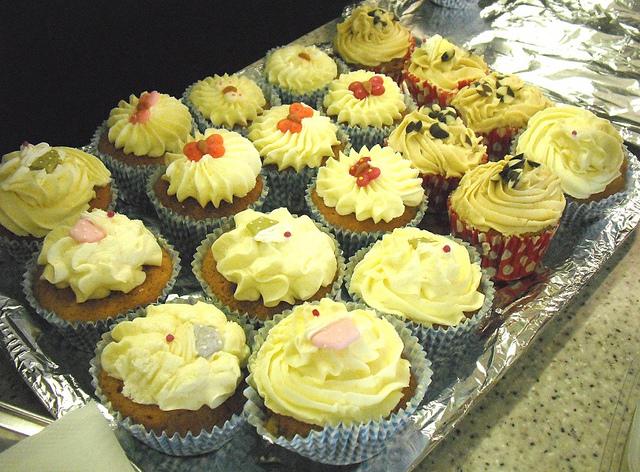How many cupcakes have red liners?
Answer briefly. 5. What is lining the pan?
Concise answer only. Foil. How many cupcakes have more than one topping?
Keep it brief. 19. 